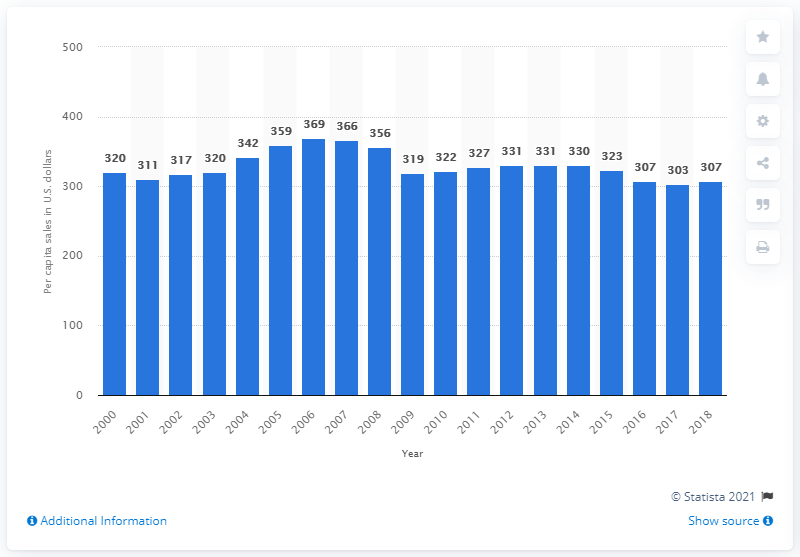Indicate a few pertinent items in this graphic. In 2018, the United States saw a total of $307 billion in electronics and appliance sales. 